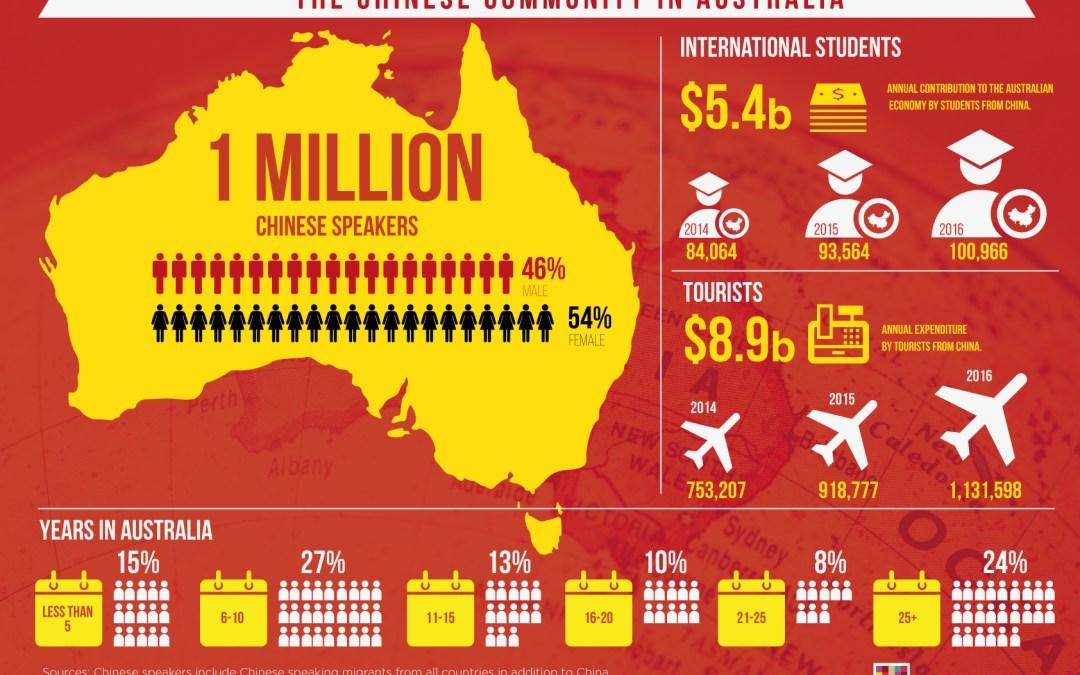Point out several critical features in this image. According to a recent study, 54% of Chinese speakers in Australia are females. According to data, 46% of Chinese speakers in Australia are males. A significant 27% of Chinese people have lived in Australia for 6-10 years. In 2015, the annual expenditure by tourists from China was 918,777. In 2016, the annual contribution to the Australian economy by students from China was estimated to be 100,966. 